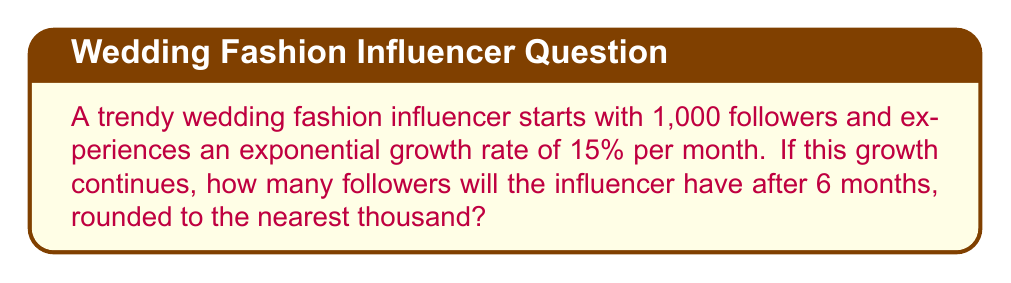Show me your answer to this math problem. Let's approach this step-by-step:

1) The initial number of followers is 1,000.

2) The monthly growth rate is 15% or 0.15.

3) We need to calculate the number of followers after 6 months.

4) The formula for exponential growth is:

   $$A = P(1 + r)^t$$

   Where:
   $A$ = Final amount
   $P$ = Initial amount (principal)
   $r$ = Growth rate (as a decimal)
   $t$ = Time periods

5) Plugging in our values:

   $$A = 1000(1 + 0.15)^6$$

6) Let's calculate:

   $$A = 1000(1.15)^6$$
   $$A = 1000(2.3131)$$
   $$A = 2313.1$$

7) Rounding to the nearest thousand:

   2313.1 rounds to 2000
Answer: 2000 followers 